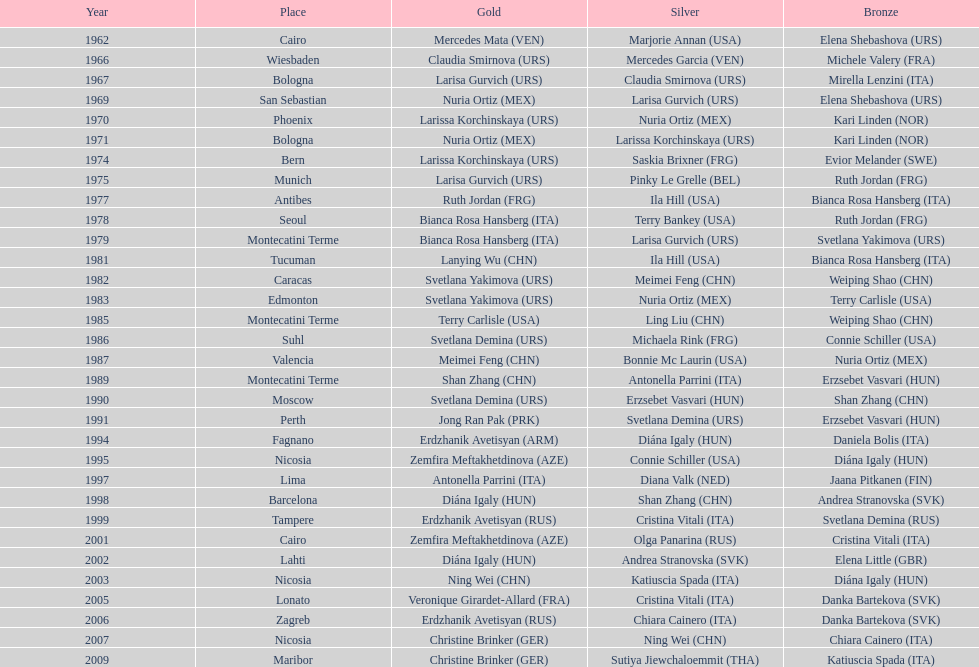What is the total number of gold medals won by the usa? 1. 